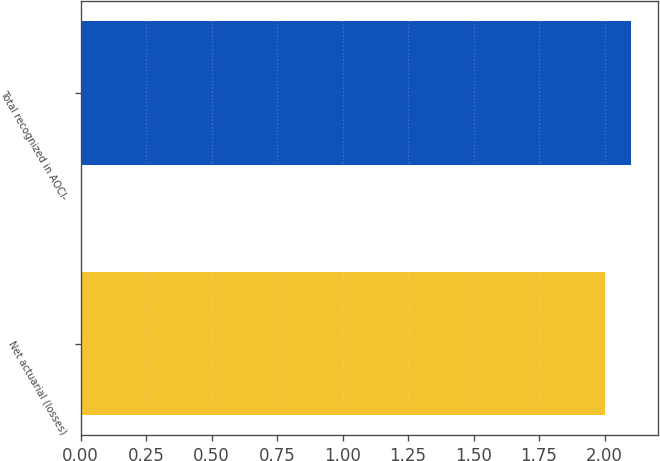Convert chart to OTSL. <chart><loc_0><loc_0><loc_500><loc_500><bar_chart><fcel>Net actuarial (losses)<fcel>Total recognized in AOCI-<nl><fcel>2<fcel>2.1<nl></chart> 